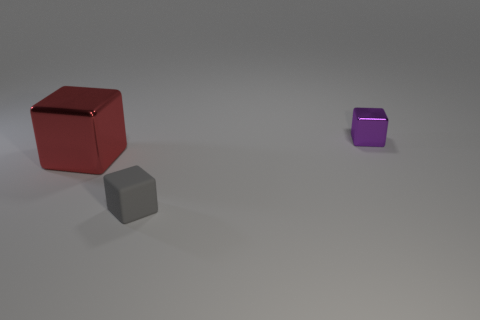Subtract all metal blocks. How many blocks are left? 1 Add 3 big shiny objects. How many objects exist? 6 Subtract 0 brown cubes. How many objects are left? 3 Subtract all large gray things. Subtract all gray rubber objects. How many objects are left? 2 Add 3 large things. How many large things are left? 4 Add 1 big purple metallic things. How many big purple metallic things exist? 1 